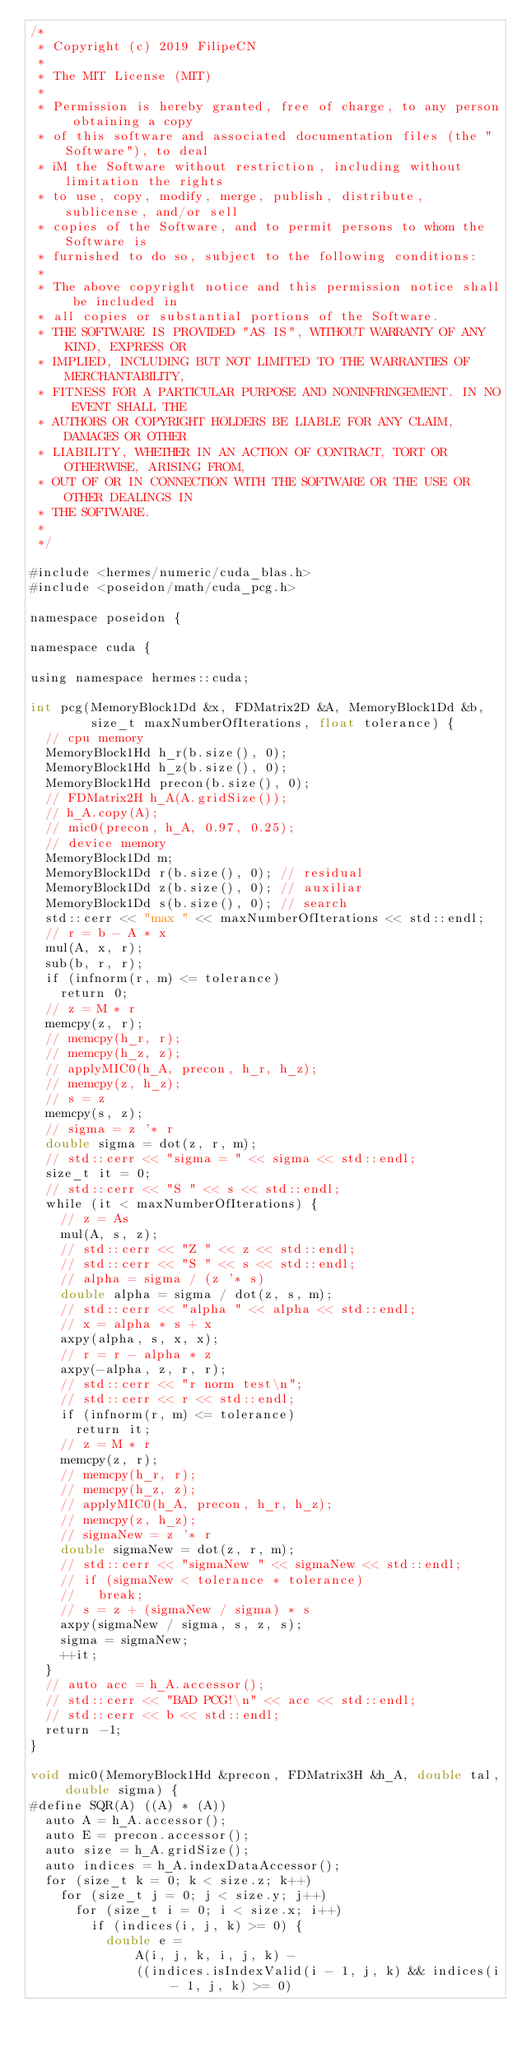<code> <loc_0><loc_0><loc_500><loc_500><_Cuda_>/*
 * Copyright (c) 2019 FilipeCN
 *
 * The MIT License (MIT)
 *
 * Permission is hereby granted, free of charge, to any person obtaining a copy
 * of this software and associated documentation files (the "Software"), to deal
 * iM the Software without restriction, including without limitation the rights
 * to use, copy, modify, merge, publish, distribute, sublicense, and/or sell
 * copies of the Software, and to permit persons to whom the Software is
 * furnished to do so, subject to the following conditions:
 *
 * The above copyright notice and this permission notice shall be included in
 * all copies or substantial portions of the Software.
 * THE SOFTWARE IS PROVIDED "AS IS", WITHOUT WARRANTY OF ANY KIND, EXPRESS OR
 * IMPLIED, INCLUDING BUT NOT LIMITED TO THE WARRANTIES OF MERCHANTABILITY,
 * FITNESS FOR A PARTICULAR PURPOSE AND NONINFRINGEMENT. IN NO EVENT SHALL THE
 * AUTHORS OR COPYRIGHT HOLDERS BE LIABLE FOR ANY CLAIM, DAMAGES OR OTHER
 * LIABILITY, WHETHER IN AN ACTION OF CONTRACT, TORT OR OTHERWISE, ARISING FROM,
 * OUT OF OR IN CONNECTION WITH THE SOFTWARE OR THE USE OR OTHER DEALINGS IN
 * THE SOFTWARE.
 *
 */

#include <hermes/numeric/cuda_blas.h>
#include <poseidon/math/cuda_pcg.h>

namespace poseidon {

namespace cuda {

using namespace hermes::cuda;

int pcg(MemoryBlock1Dd &x, FDMatrix2D &A, MemoryBlock1Dd &b,
        size_t maxNumberOfIterations, float tolerance) {
  // cpu memory
  MemoryBlock1Hd h_r(b.size(), 0);
  MemoryBlock1Hd h_z(b.size(), 0);
  MemoryBlock1Hd precon(b.size(), 0);
  // FDMatrix2H h_A(A.gridSize());
  // h_A.copy(A);
  // mic0(precon, h_A, 0.97, 0.25);
  // device memory
  MemoryBlock1Dd m;
  MemoryBlock1Dd r(b.size(), 0); // residual
  MemoryBlock1Dd z(b.size(), 0); // auxiliar
  MemoryBlock1Dd s(b.size(), 0); // search
  std::cerr << "max " << maxNumberOfIterations << std::endl;
  // r = b - A * x
  mul(A, x, r);
  sub(b, r, r);
  if (infnorm(r, m) <= tolerance)
    return 0;
  // z = M * r
  memcpy(z, r);
  // memcpy(h_r, r);
  // memcpy(h_z, z);
  // applyMIC0(h_A, precon, h_r, h_z);
  // memcpy(z, h_z);
  // s = z
  memcpy(s, z);
  // sigma = z '* r
  double sigma = dot(z, r, m);
  // std::cerr << "sigma = " << sigma << std::endl;
  size_t it = 0;
  // std::cerr << "S " << s << std::endl;
  while (it < maxNumberOfIterations) {
    // z = As
    mul(A, s, z);
    // std::cerr << "Z " << z << std::endl;
    // std::cerr << "S " << s << std::endl;
    // alpha = sigma / (z '* s)
    double alpha = sigma / dot(z, s, m);
    // std::cerr << "alpha " << alpha << std::endl;
    // x = alpha * s + x
    axpy(alpha, s, x, x);
    // r = r - alpha * z
    axpy(-alpha, z, r, r);
    // std::cerr << "r norm test\n";
    // std::cerr << r << std::endl;
    if (infnorm(r, m) <= tolerance)
      return it;
    // z = M * r
    memcpy(z, r);
    // memcpy(h_r, r);
    // memcpy(h_z, z);
    // applyMIC0(h_A, precon, h_r, h_z);
    // memcpy(z, h_z);
    // sigmaNew = z '* r
    double sigmaNew = dot(z, r, m);
    // std::cerr << "sigmaNew " << sigmaNew << std::endl;
    // if (sigmaNew < tolerance * tolerance)
    //   break;
    // s = z + (sigmaNew / sigma) * s
    axpy(sigmaNew / sigma, s, z, s);
    sigma = sigmaNew;
    ++it;
  }
  // auto acc = h_A.accessor();
  // std::cerr << "BAD PCG!\n" << acc << std::endl;
  // std::cerr << b << std::endl;
  return -1;
}

void mic0(MemoryBlock1Hd &precon, FDMatrix3H &h_A, double tal, double sigma) {
#define SQR(A) ((A) * (A))
  auto A = h_A.accessor();
  auto E = precon.accessor();
  auto size = h_A.gridSize();
  auto indices = h_A.indexDataAccessor();
  for (size_t k = 0; k < size.z; k++)
    for (size_t j = 0; j < size.y; j++)
      for (size_t i = 0; i < size.x; i++)
        if (indices(i, j, k) >= 0) {
          double e =
              A(i, j, k, i, j, k) -
              ((indices.isIndexValid(i - 1, j, k) && indices(i - 1, j, k) >= 0)</code> 